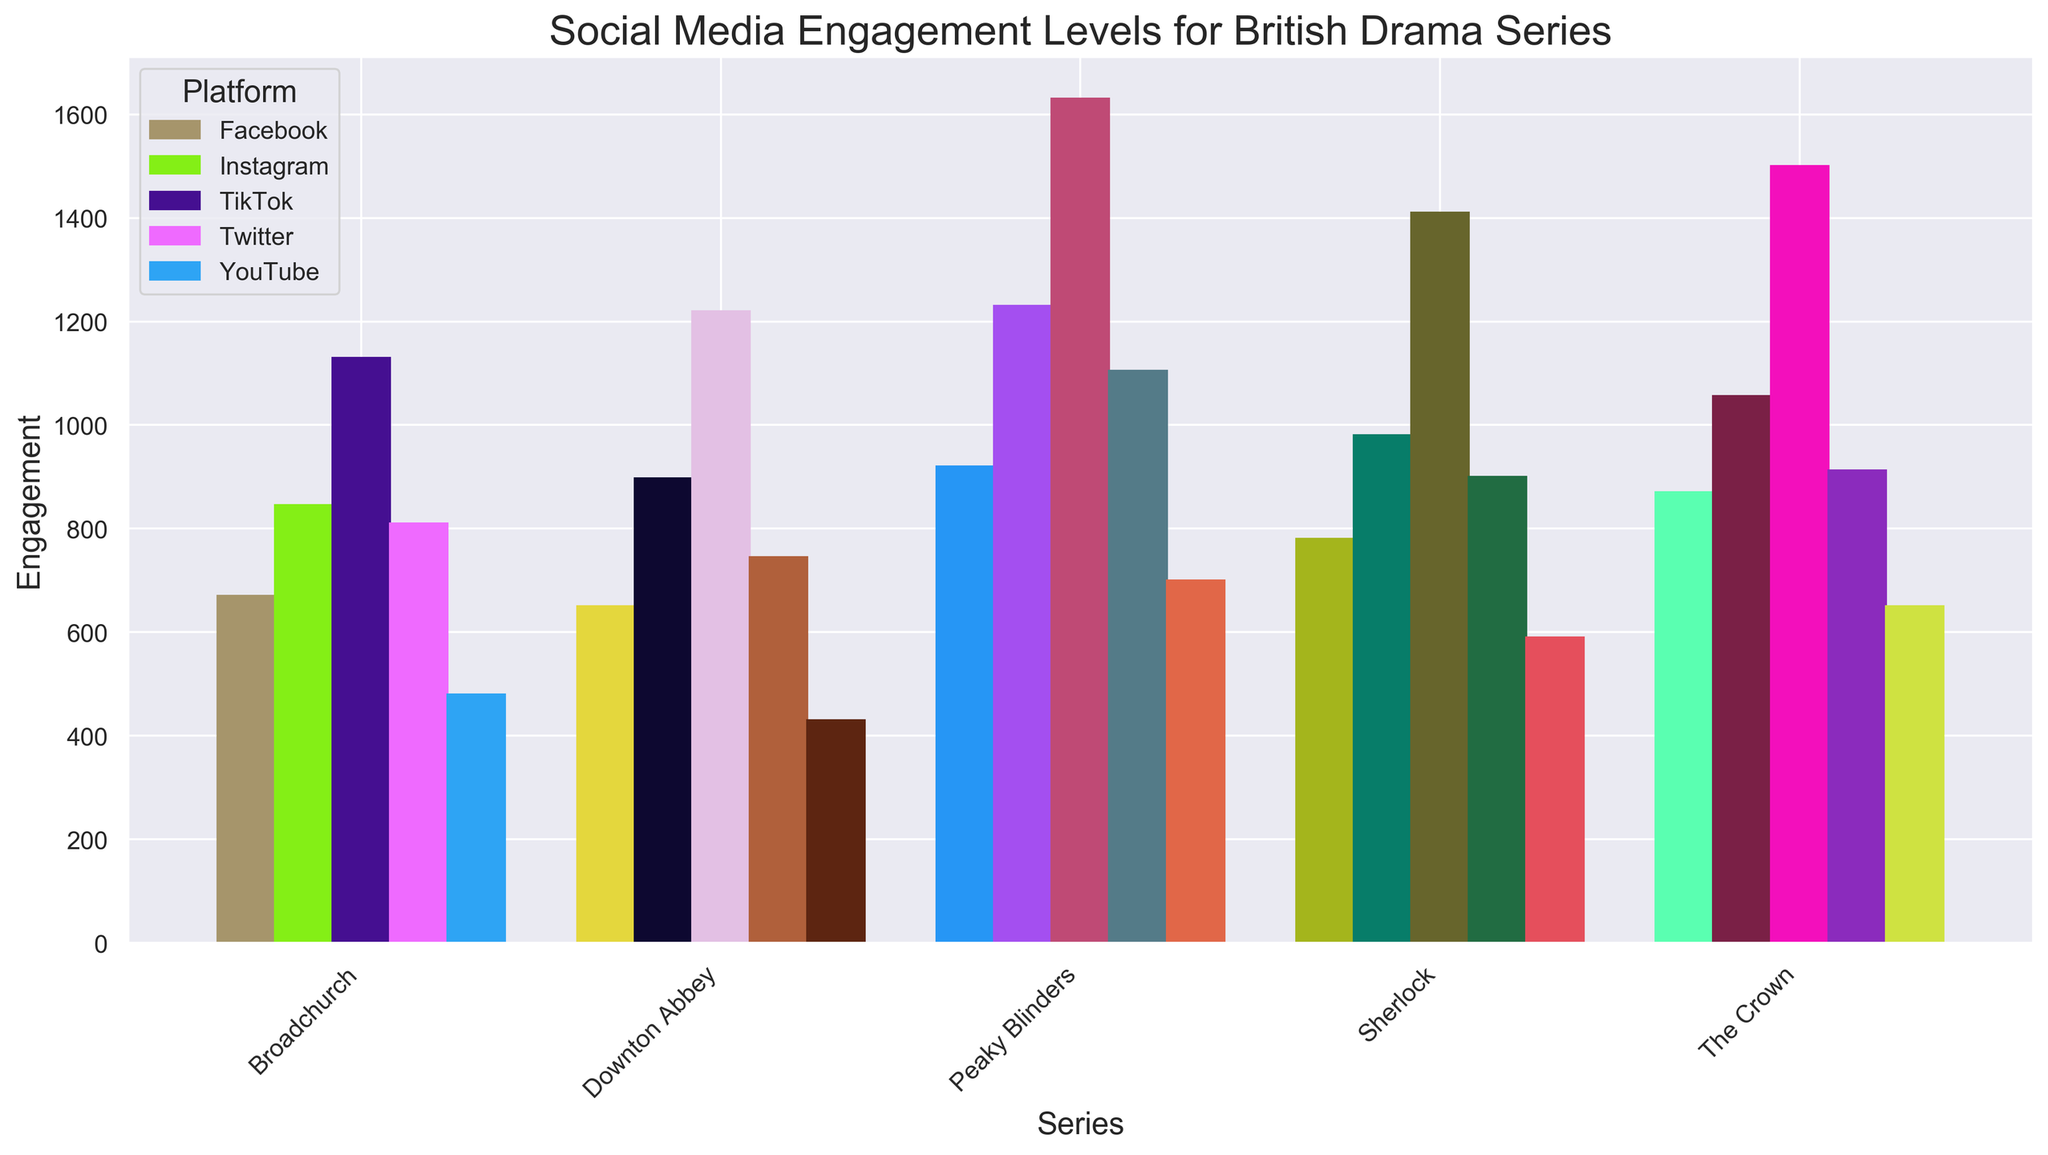Which British drama series has the highest social media engagement on TikTok? By looking at the TikTok bars for each series, "Peaky Blinders" has the tallest bar, indicating the highest engagement.
Answer: Peaky Blinders What is the total social media engagement for "The Crown" across all platforms? Summing the engagement of "The Crown" from Instagram (1056), Twitter (912), Facebook (870), YouTube (650), and TikTok (1500): 1056 + 912 + 870 + 650 + 1500 = 4988
Answer: 4988 Does "Sherlock" have higher engagement on Instagram or Twitter? Comparing the heights of the Instagram and Twitter bars for "Sherlock," the Instagram bar is slightly taller (980) than the Twitter bar (900).
Answer: Instagram Which platform shows the lowest engagement for "Downton Abbey"? Comparing the bars for "Downton Abbey" across platforms, YouTube has the shortest bar with an engagement of 430.
Answer: YouTube Of the five drama series, which has the most consistent engagement across all platforms? By comparing the lengths of the bars for each series across platforms, "Peaky Blinders" has fairly tall and relatively consistent bars across all platforms.
Answer: Peaky Blinders How much greater is the engagement for "Peaky Blinders" on TikTok compared to Facebook? Engagement on TikTok for "Peaky Blinders" is 1630, and on Facebook, it is 920. The difference is 1630 - 920 = 710.
Answer: 710 Which series has the smallest difference in engagement between Instagram and Twitter? Calculating the engagement difference between Instagram and Twitter for each series: Downton Abbey (897-745=152), The Crown (1056-912=144), Peaky Blinders (1230-1105=125), Sherlock (980-900=80), Broadchurch (845-810=35). "Broadchurch" has the smallest difference at 35.
Answer: Broadchurch Are there more total engagements on Facebook for "The Crown" compared to Instagram for "Downton Abbey"? "The Crown" has 870 engagements on Facebook, "Downton Abbey" has 897 engagements on Instagram. Comparing 870 and 897, Instagram for "Downton Abbey" has more.
Answer: No On which platform does "Broadchurch" see its highest engagement? Observing the bars for "Broadchurch," TikTok has the highest bar with an engagement of 1130.
Answer: TikTok 